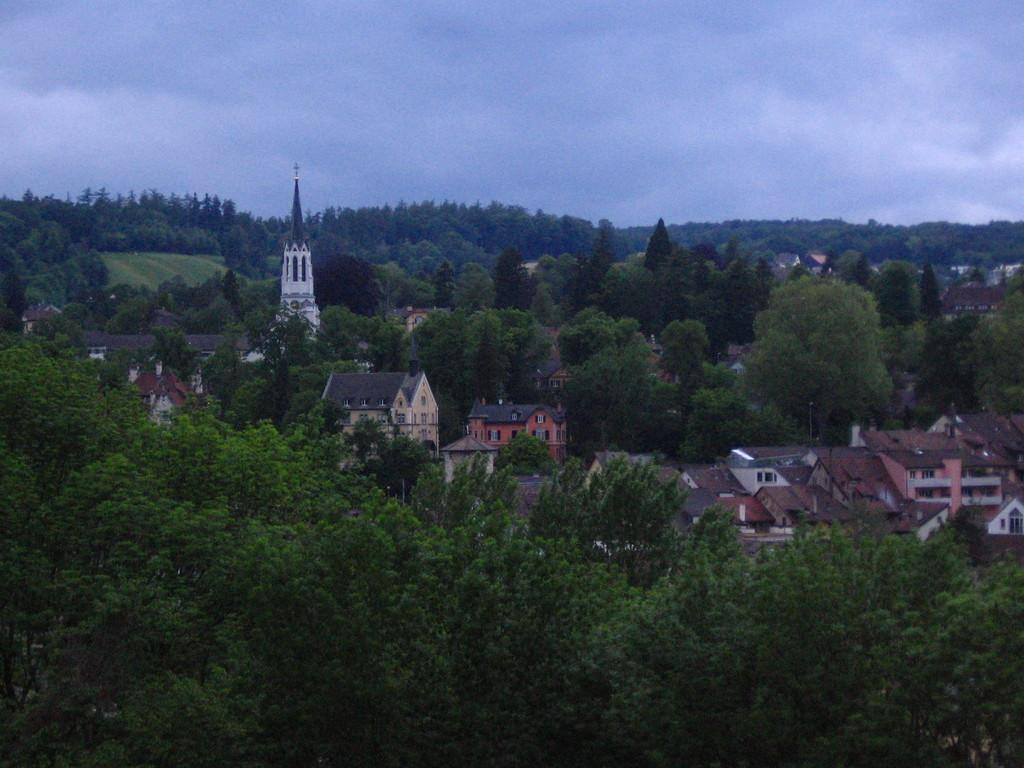What type of natural elements can be seen in the image? There are trees in the image. What type of man-made structures are present in the image? There are buildings in the image. What part of the natural environment is visible in the image? The sky is visible in the image. What is the condition of the sky in the image? The sky appears to be cloudy in the image. How many brothers are sitting on the seat in the image? There is no seat or brothers present in the image. What type of boundary can be seen between the trees and buildings in the image? There is no boundary visible between the trees and buildings in the image. 